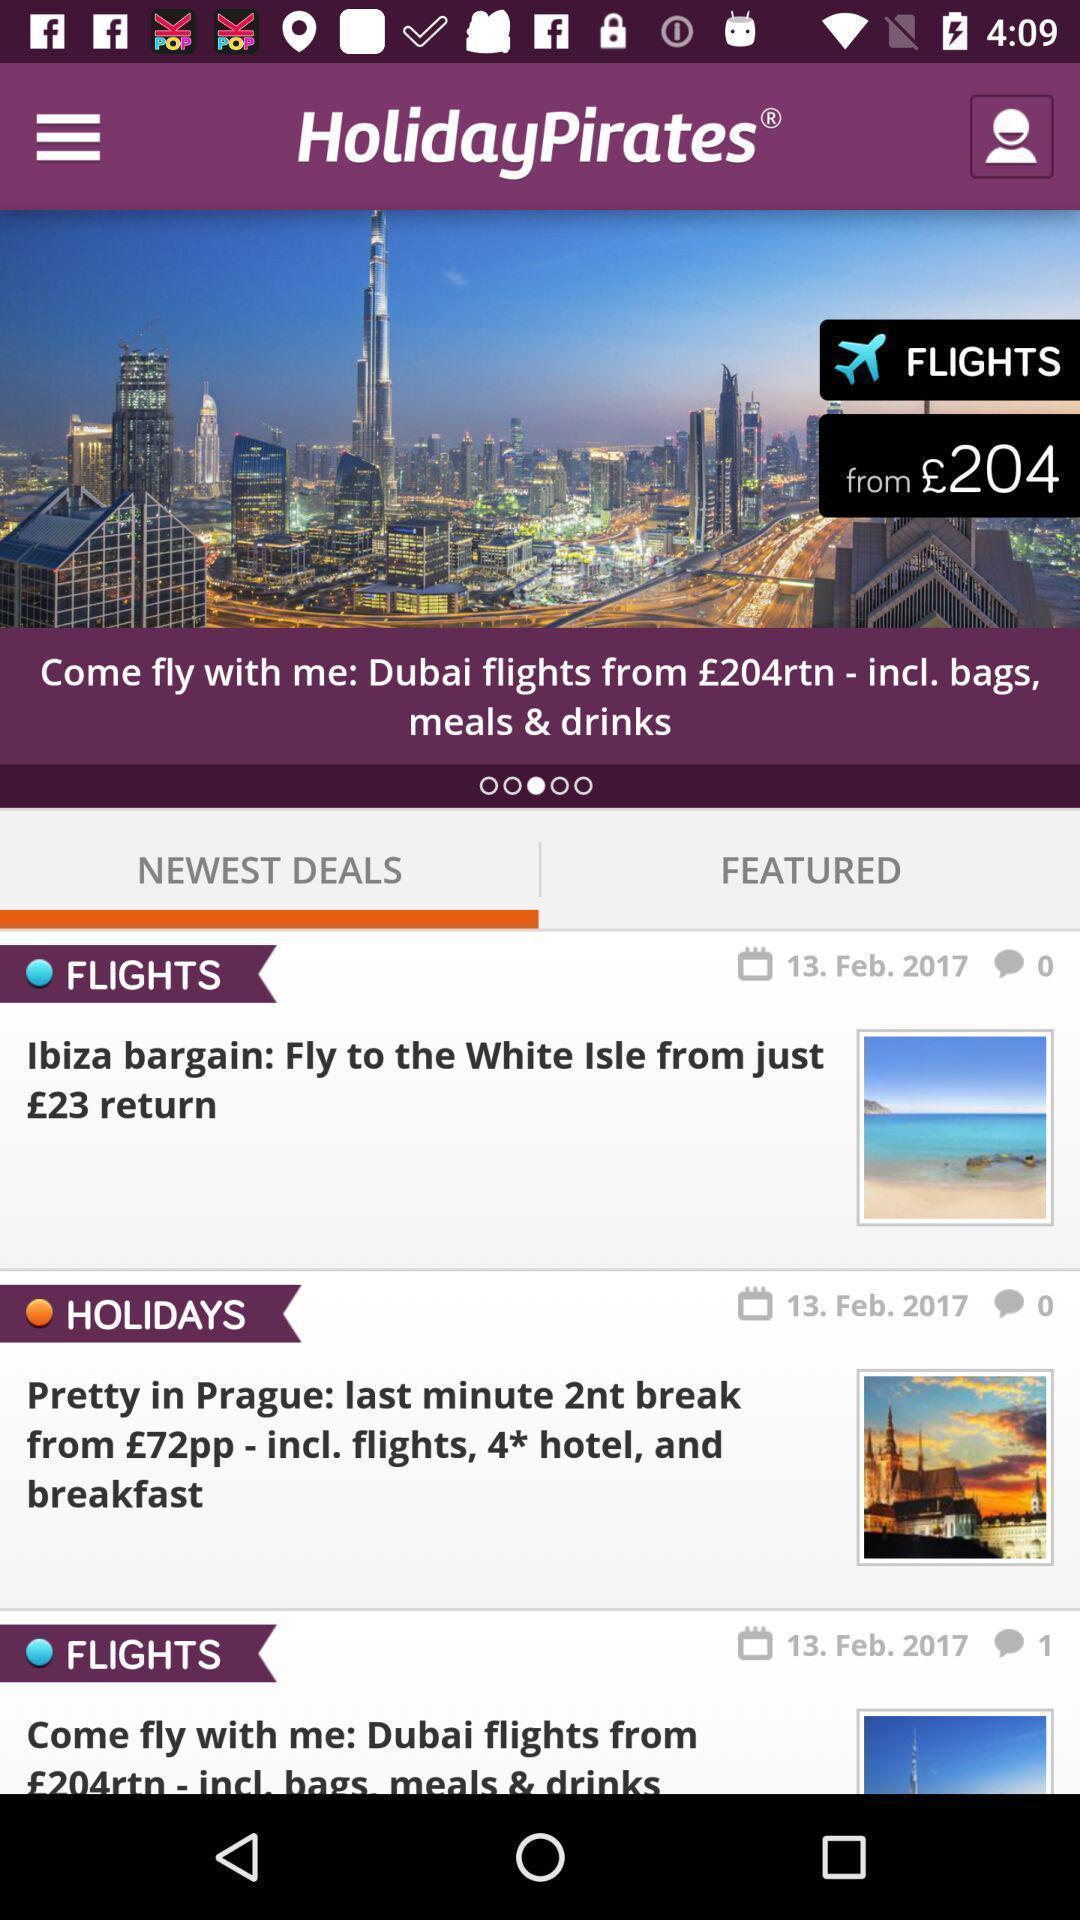Give me a narrative description of this picture. Screen shows newest deals of vacations. 